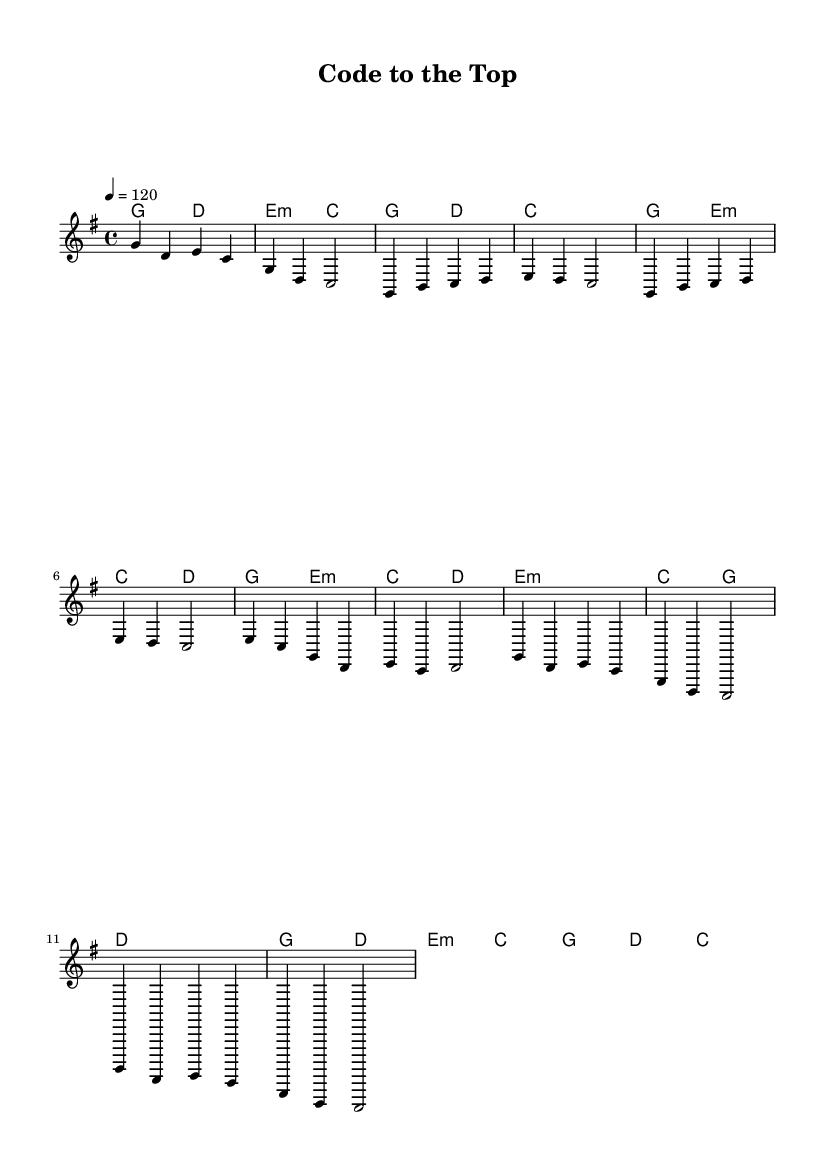What is the key signature of this music? The key signature is G major, which has one sharp (F#).
Answer: G major What is the time signature? The time signature is 4/4, indicating four beats in each measure.
Answer: 4/4 What is the tempo marking? The tempo marking indicates a speed of 120 beats per minute.
Answer: 120 How many measures are in the Chorus section? The Chorus section consists of four measures as indicated by the respective note groupings.
Answer: 4 What chords are used in the Pre-Chorus? The Pre-Chorus uses the chords E minor, C major, and D major.
Answer: E minor, C major, D major What is the first note of the Verse? The first note of the Verse is G.
Answer: G How many different sections are there in this piece? The piece has four sections: Intro, Verse, Pre-Chorus, and Chorus, as indicated by the music formatting.
Answer: 4 